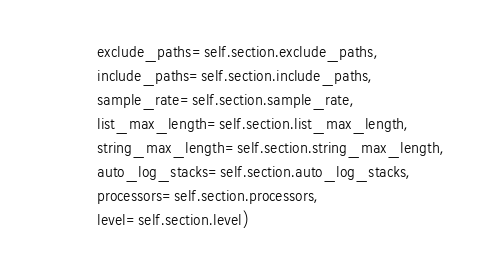Convert code to text. <code><loc_0><loc_0><loc_500><loc_500><_Python_>            exclude_paths=self.section.exclude_paths,
            include_paths=self.section.include_paths,
            sample_rate=self.section.sample_rate,
            list_max_length=self.section.list_max_length,
            string_max_length=self.section.string_max_length,
            auto_log_stacks=self.section.auto_log_stacks,
            processors=self.section.processors,
            level=self.section.level)
</code> 